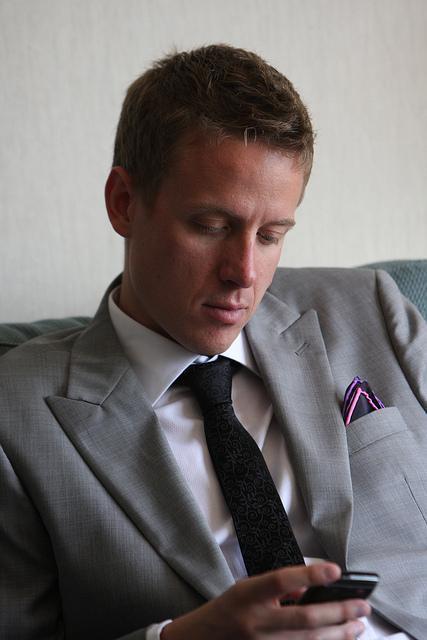How many people are there?
Give a very brief answer. 1. 